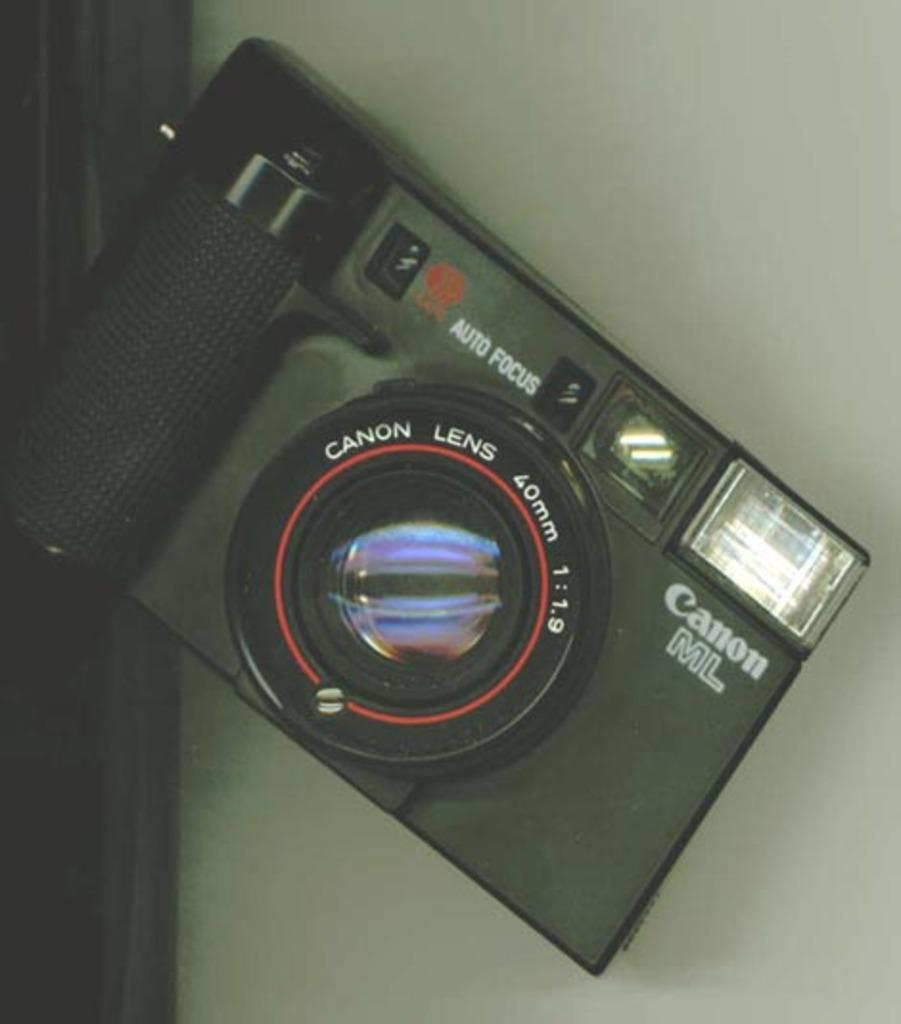What is the main object in the image? There is a table in the image. What is placed on the table? There is a camera on the table. How does the camera contribute to pollution in the image? The image does not show any pollution, and the camera itself does not contribute to pollution. 